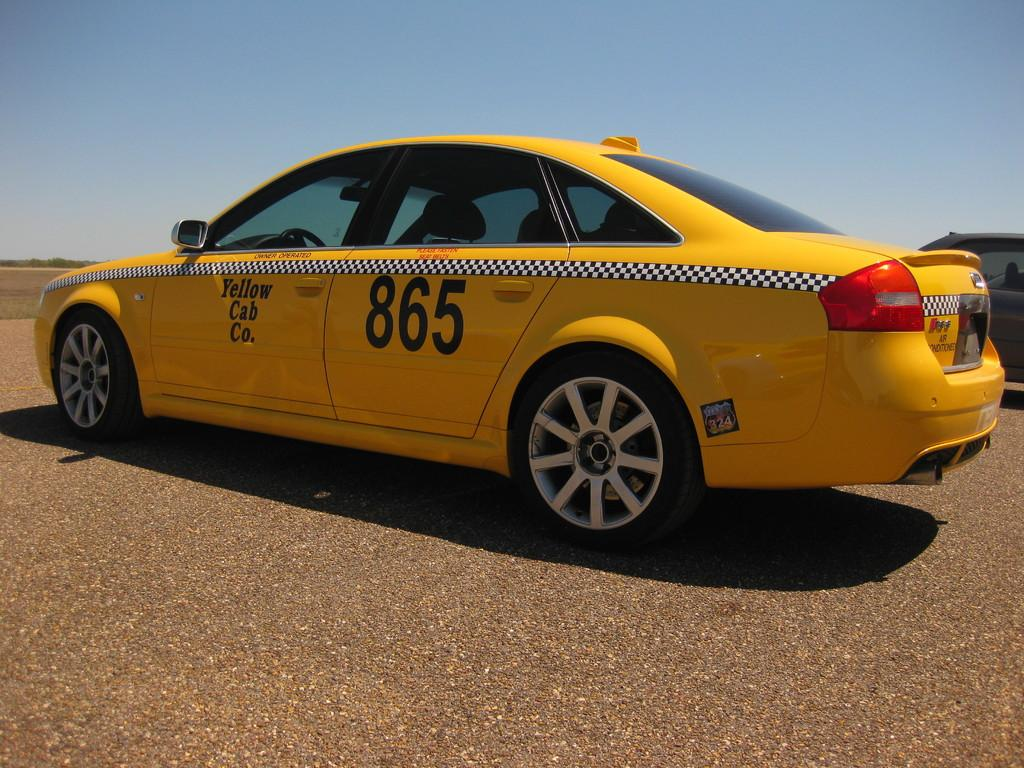<image>
Present a compact description of the photo's key features. a taxi that has the number 865 on it 